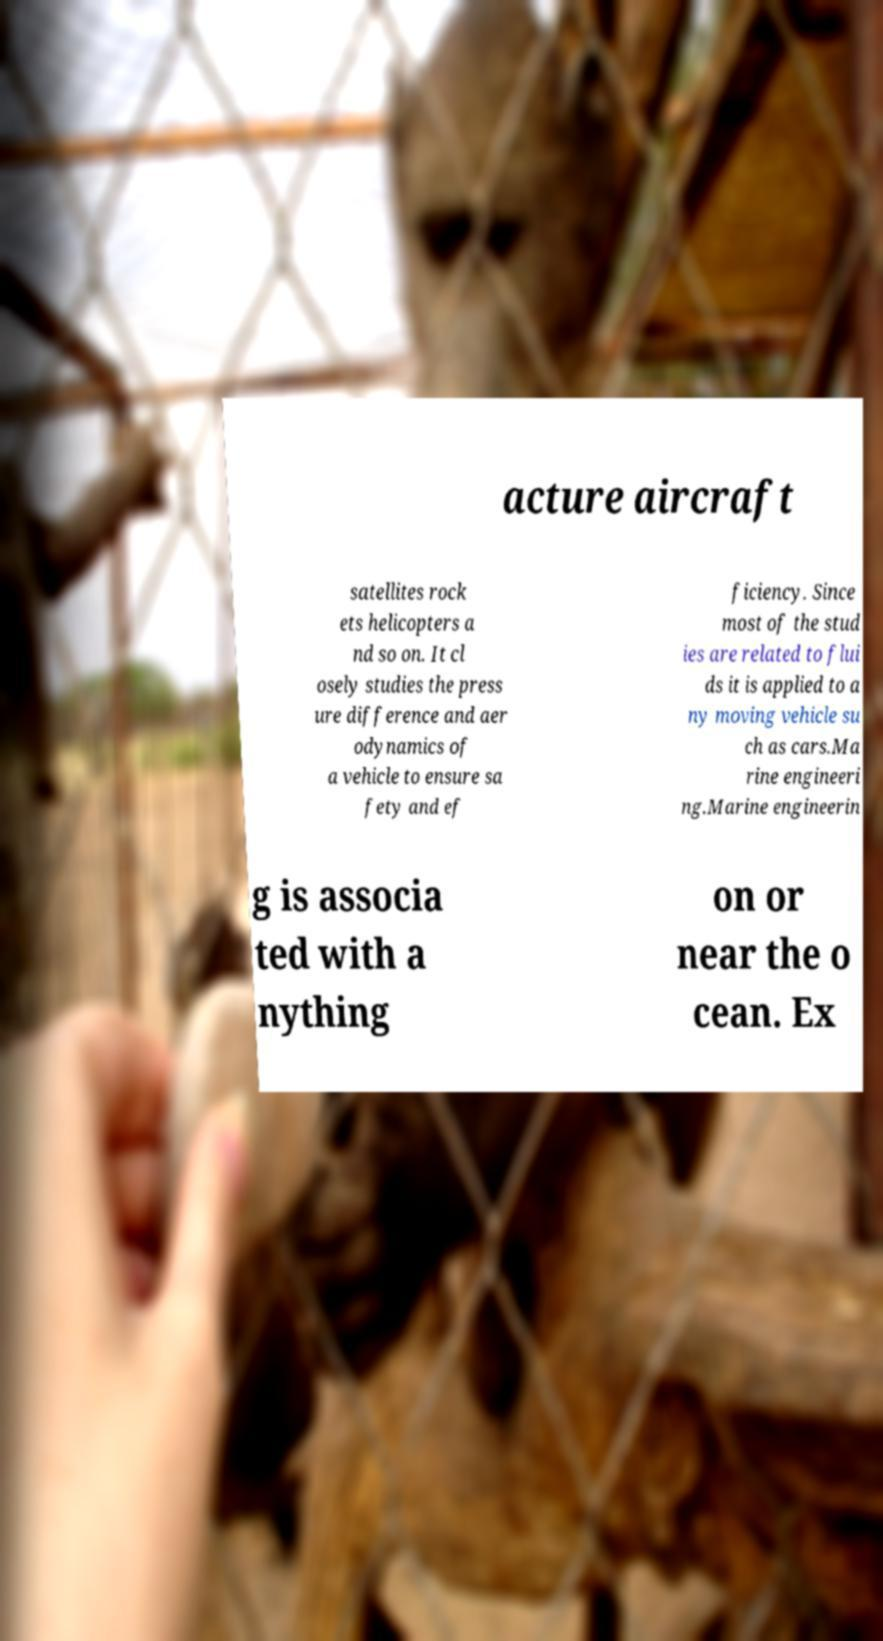Can you read and provide the text displayed in the image?This photo seems to have some interesting text. Can you extract and type it out for me? acture aircraft satellites rock ets helicopters a nd so on. It cl osely studies the press ure difference and aer odynamics of a vehicle to ensure sa fety and ef ficiency. Since most of the stud ies are related to flui ds it is applied to a ny moving vehicle su ch as cars.Ma rine engineeri ng.Marine engineerin g is associa ted with a nything on or near the o cean. Ex 